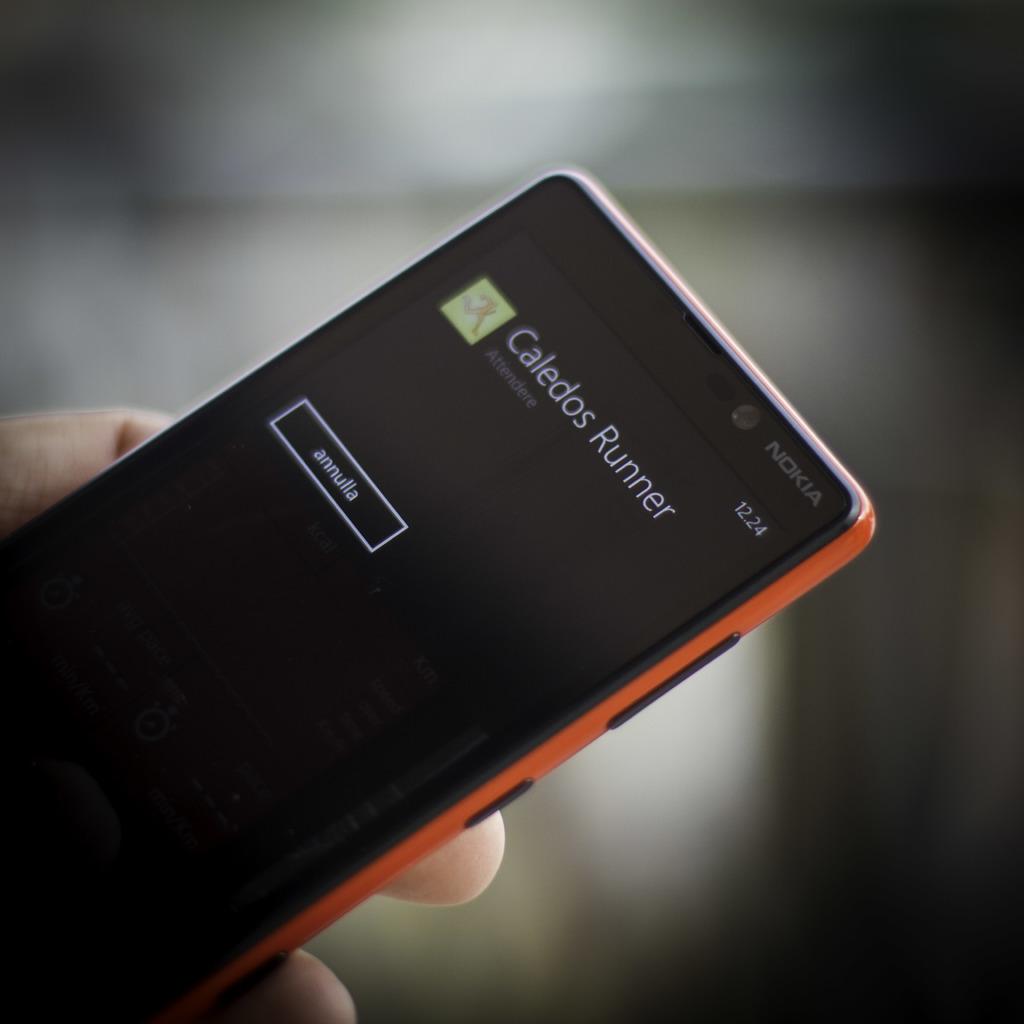What is the name of the app that is open?
Your answer should be very brief. Caledos runner. What is the brand of this phone?
Provide a short and direct response. Nokia. 